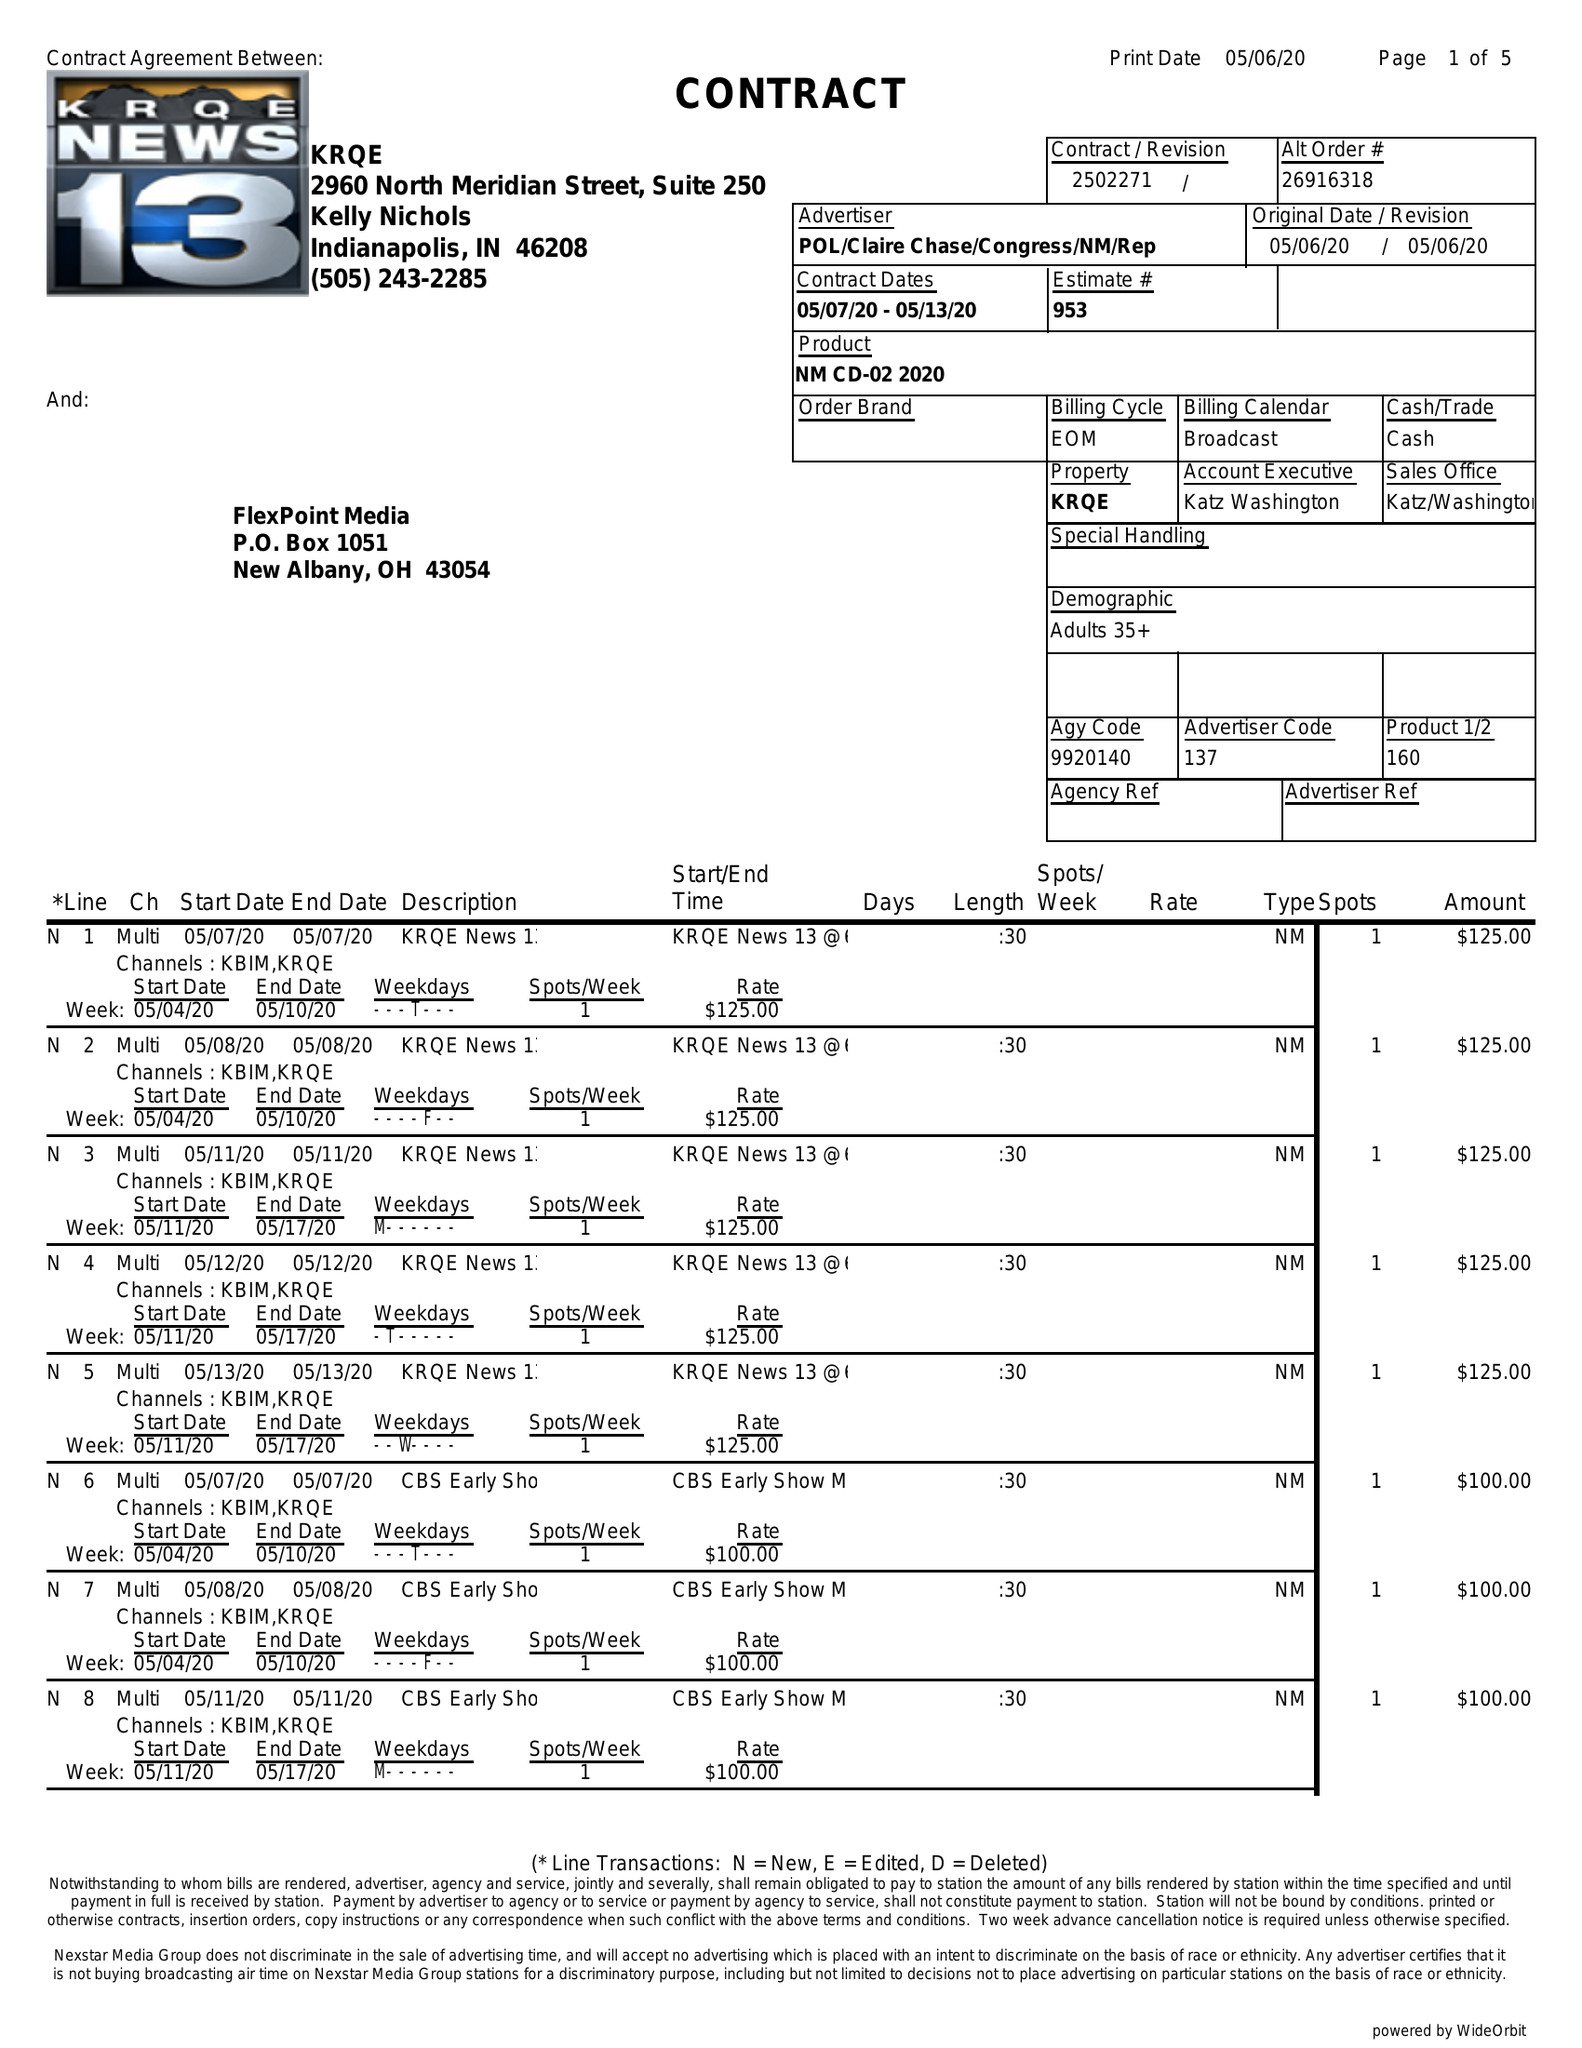What is the value for the contract_num?
Answer the question using a single word or phrase. 2502271 